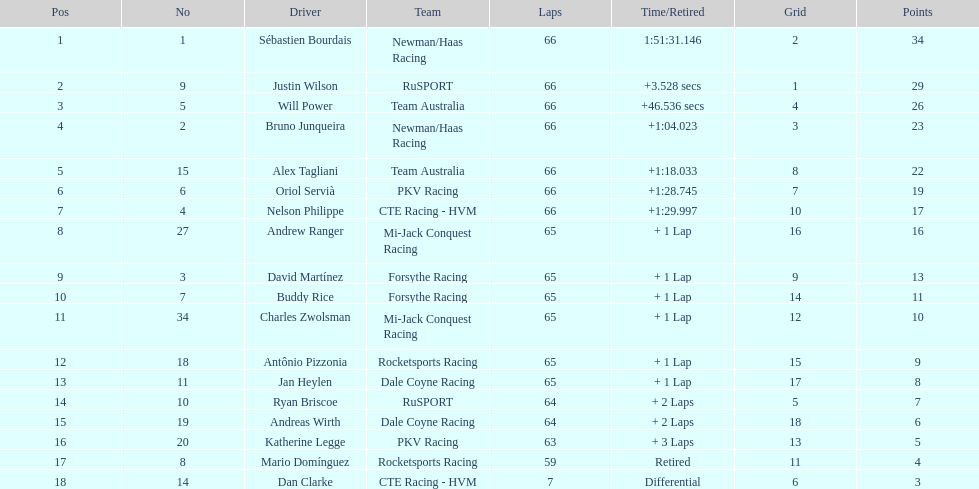Which teams participated in the 2006 gran premio telmex? Newman/Haas Racing, RuSPORT, Team Australia, Newman/Haas Racing, Team Australia, PKV Racing, CTE Racing - HVM, Mi-Jack Conquest Racing, Forsythe Racing, Forsythe Racing, Mi-Jack Conquest Racing, Rocketsports Racing, Dale Coyne Racing, RuSPORT, Dale Coyne Racing, PKV Racing, Rocketsports Racing, CTE Racing - HVM. Who were the drivers of these teams? Sébastien Bourdais, Justin Wilson, Will Power, Bruno Junqueira, Alex Tagliani, Oriol Servià, Nelson Philippe, Andrew Ranger, David Martínez, Buddy Rice, Charles Zwolsman, Antônio Pizzonia, Jan Heylen, Ryan Briscoe, Andreas Wirth, Katherine Legge, Mario Domínguez, Dan Clarke. Which driver finished last? Dan Clarke. 